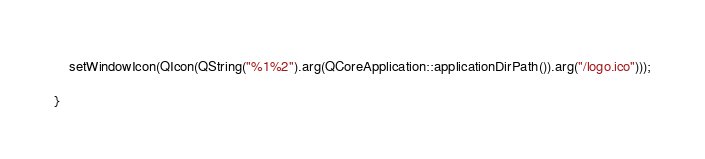<code> <loc_0><loc_0><loc_500><loc_500><_C++_>	setWindowIcon(QIcon(QString("%1%2").arg(QCoreApplication::applicationDirPath()).arg("/logo.ico")));

}
</code> 